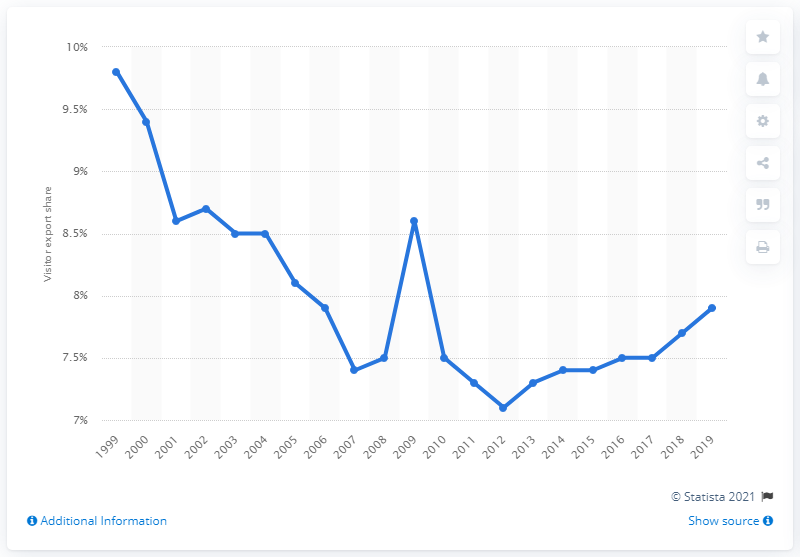Give some essential details in this illustration. In 2012, visitor exports in Italy increased from 7 percent to 8 percent. 